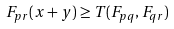Convert formula to latex. <formula><loc_0><loc_0><loc_500><loc_500>F _ { p r } ( x + y ) \geq T ( F _ { p q } , F _ { q r } )</formula> 